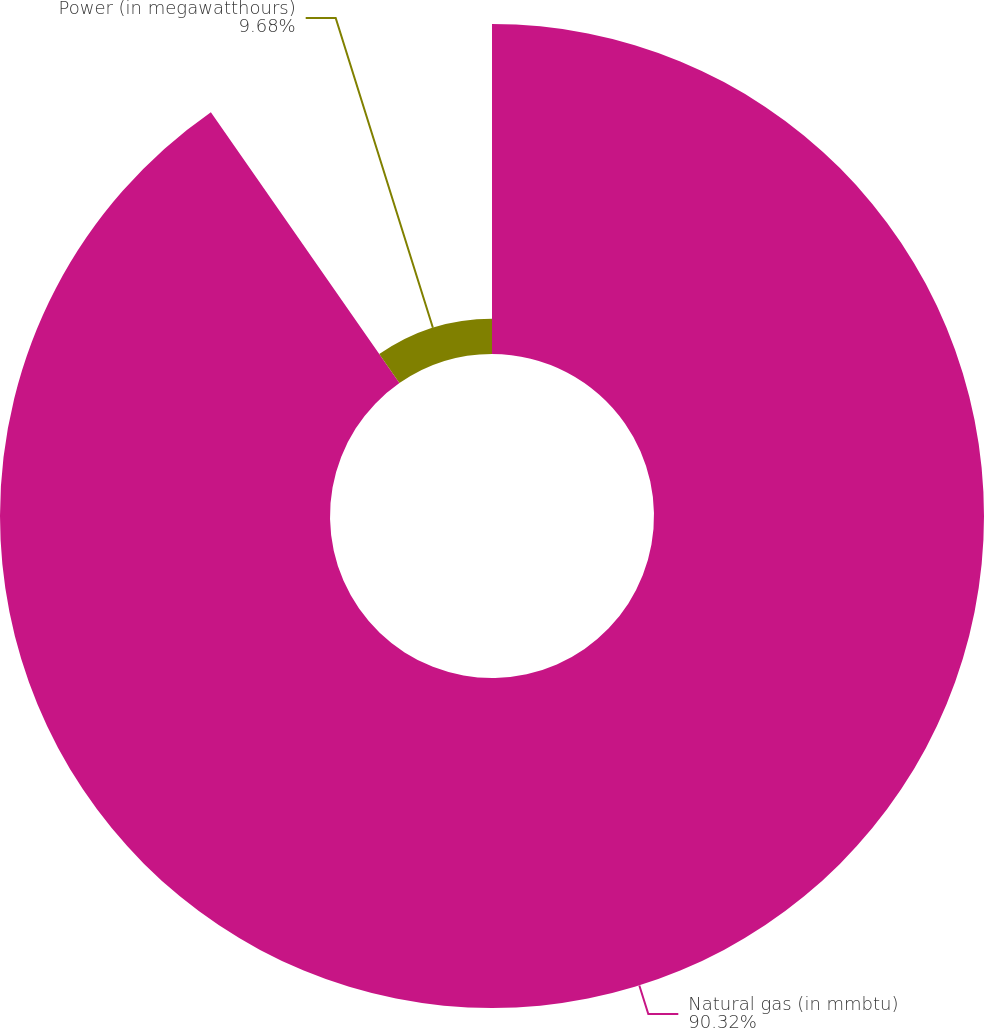Convert chart. <chart><loc_0><loc_0><loc_500><loc_500><pie_chart><fcel>Natural gas (in mmbtu)<fcel>Power (in megawatthours)<nl><fcel>90.32%<fcel>9.68%<nl></chart> 